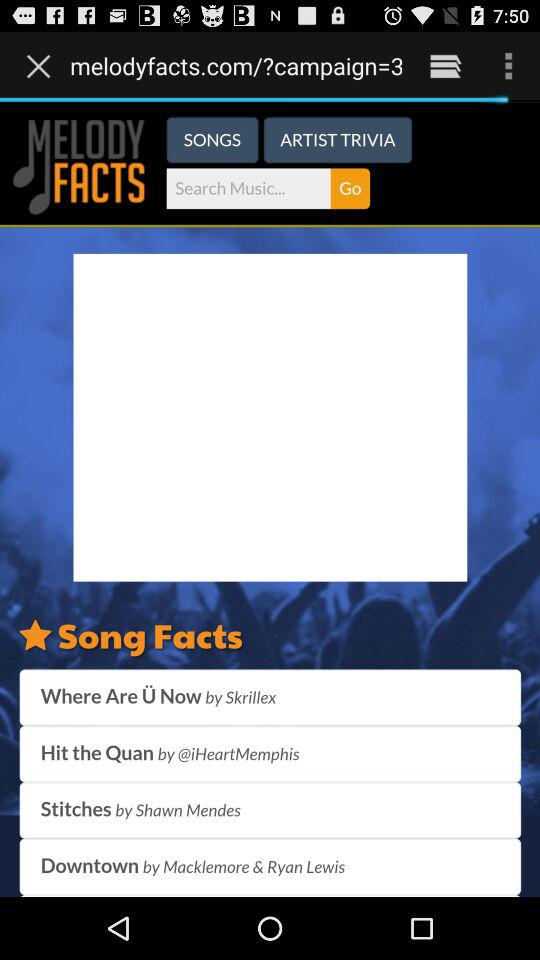By whom is "Where Are Ü Now" sung? "Where Are Ü Now" is sung by "Skrillex". 